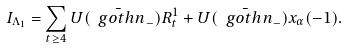Convert formula to latex. <formula><loc_0><loc_0><loc_500><loc_500>I _ { \Lambda _ { 1 } } = \sum _ { t \geq 4 } U ( \bar { \ g o t h { n } } _ { - } ) R _ { t } ^ { 1 } + U ( \bar { \ g o t h { n } } _ { - } ) x _ { \alpha } ( - 1 ) .</formula> 